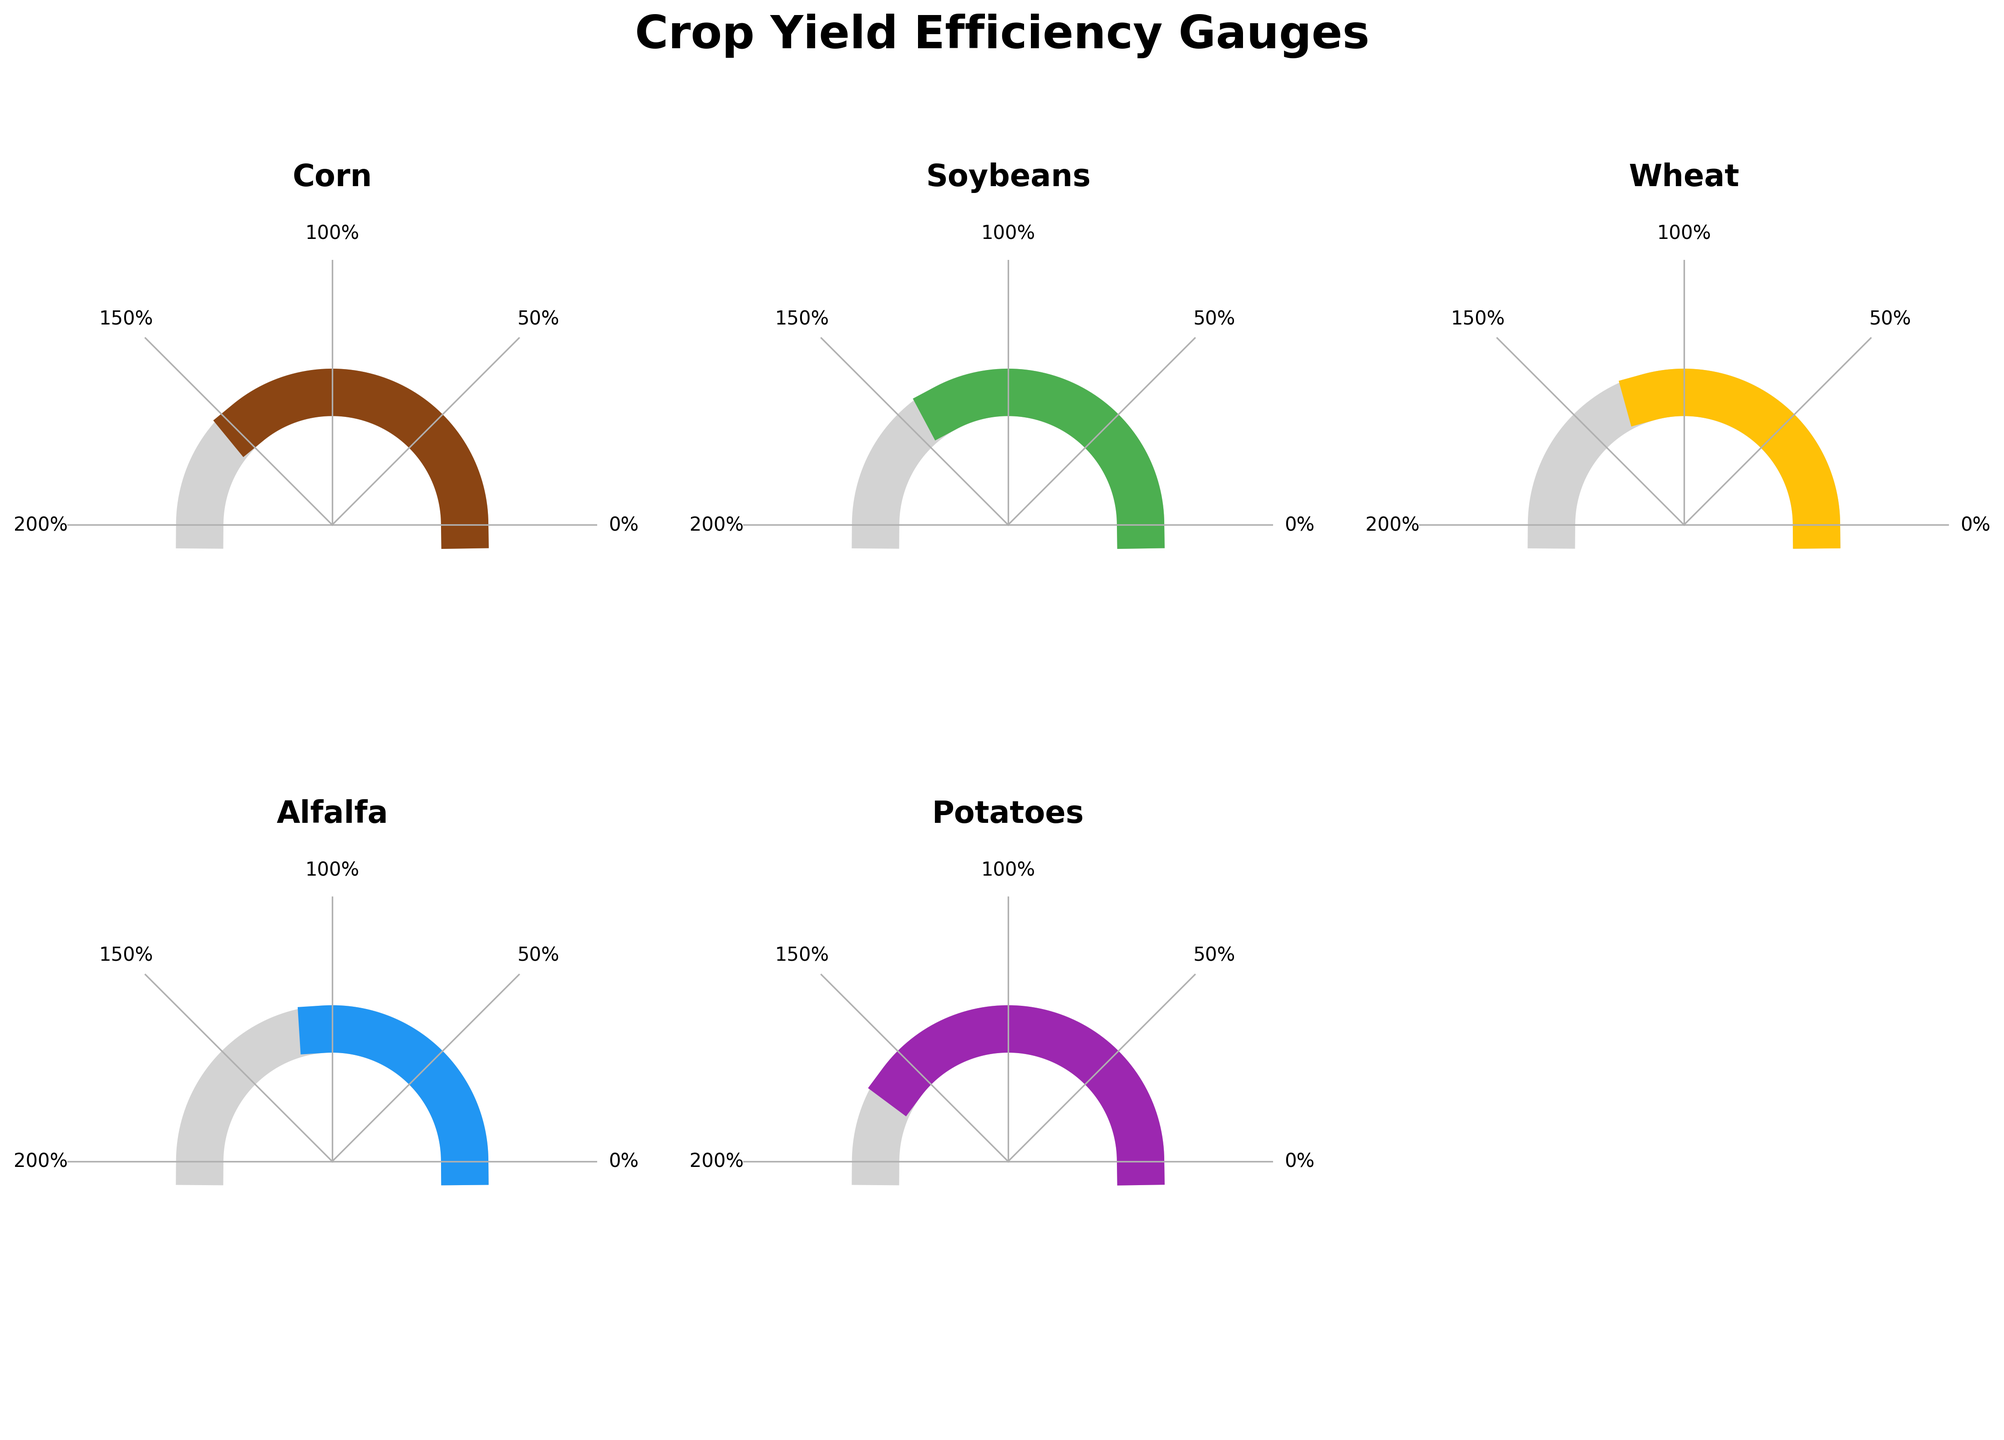What is the title of the figure? The title is displayed at the top center of the figure. It reads 'Crop Yield Efficiency Gauges'.
Answer: Crop Yield Efficiency Gauges How many crops are represented in the figure? By counting the individual gauges, we observe that there are five main crops shown: Corn, Soybeans, Wheat, Alfalfa, and Potatoes.
Answer: 5 Which crop has the highest yield efficiency? By observing the gauges and the efficiency percentages within them, we can see that Potatoes has the highest yield efficiency at 160%.
Answer: Potatoes What is the yield efficiency of Corn? The gauge for Corn shows an efficiency percentage right in the middle of the gauge: 145%.
Answer: 145% What are the efficiency percentages for Soybeans and Wheat? The efficiency percentages are shown in their respective gauges: Soybeans has 132% and Wheat has 118%.
Answer: Soybeans: 132%, Wheat: 118% Which crop has the lowest yield efficiency? Among the gauges, Alfalfa has the lowest yield efficiency at 105%.
Answer: Alfalfa What is the difference in yield efficiency between Corn and Alfalfa? The yield efficiency of Corn is 145% and Alfalfa is 105%. The difference is calculated by subtracting 105 from 145.
Answer: 40% Which crops have a yield efficiency greater than the regional average of 100%? By observing all the gauges, all the crops (Corn, Soybeans, Wheat, Alfalfa, and Potatoes) have efficiencies greater than 100%.
Answer: Corn, Soybeans, Wheat, Alfalfa, Potatoes What is the average yield efficiency of all the crops shown? The efficiencies are: 145% (Corn), 132% (Soybeans), 118% (Wheat), 105% (Alfalfa), 160% (Potatoes). Sum them up and divide by the number of crops: (145 + 132 + 118 + 105 + 160)/5 = 660/5.
Answer: 132% Which crop has a yield efficiency closest to 150%? By observing the gauges, Corn at 145% is closest to 150% when comparing it to the efficiencies of other crops.
Answer: Corn 